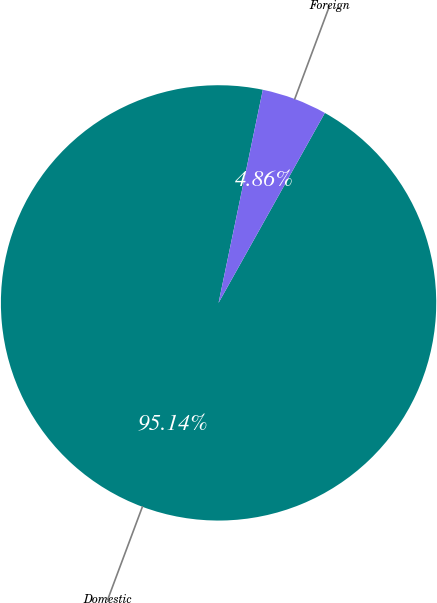Convert chart. <chart><loc_0><loc_0><loc_500><loc_500><pie_chart><fcel>Domestic<fcel>Foreign<nl><fcel>95.14%<fcel>4.86%<nl></chart> 